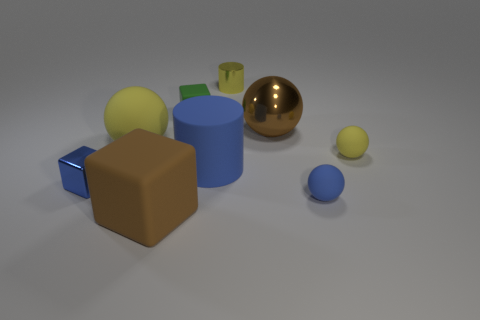What number of objects are either green rubber cubes or small cubes behind the small blue metallic cube?
Your answer should be compact. 1. What is the color of the small rubber ball that is behind the small block left of the small matte block?
Give a very brief answer. Yellow. How many other things are there of the same material as the yellow cylinder?
Offer a very short reply. 2. How many rubber objects are brown cubes or tiny yellow objects?
Your answer should be compact. 2. There is a matte object that is the same shape as the yellow metallic object; what is its color?
Your answer should be very brief. Blue. What number of things are matte balls or large blue cylinders?
Provide a short and direct response. 4. What is the shape of the large blue thing that is made of the same material as the tiny yellow sphere?
Ensure brevity in your answer.  Cylinder. What number of tiny things are either green matte blocks or metallic cubes?
Provide a succinct answer. 2. What number of other objects are there of the same color as the big matte cylinder?
Offer a very short reply. 2. There is a large blue matte object that is right of the small metallic block that is in front of the large metallic ball; what number of brown balls are to the right of it?
Give a very brief answer. 1. 